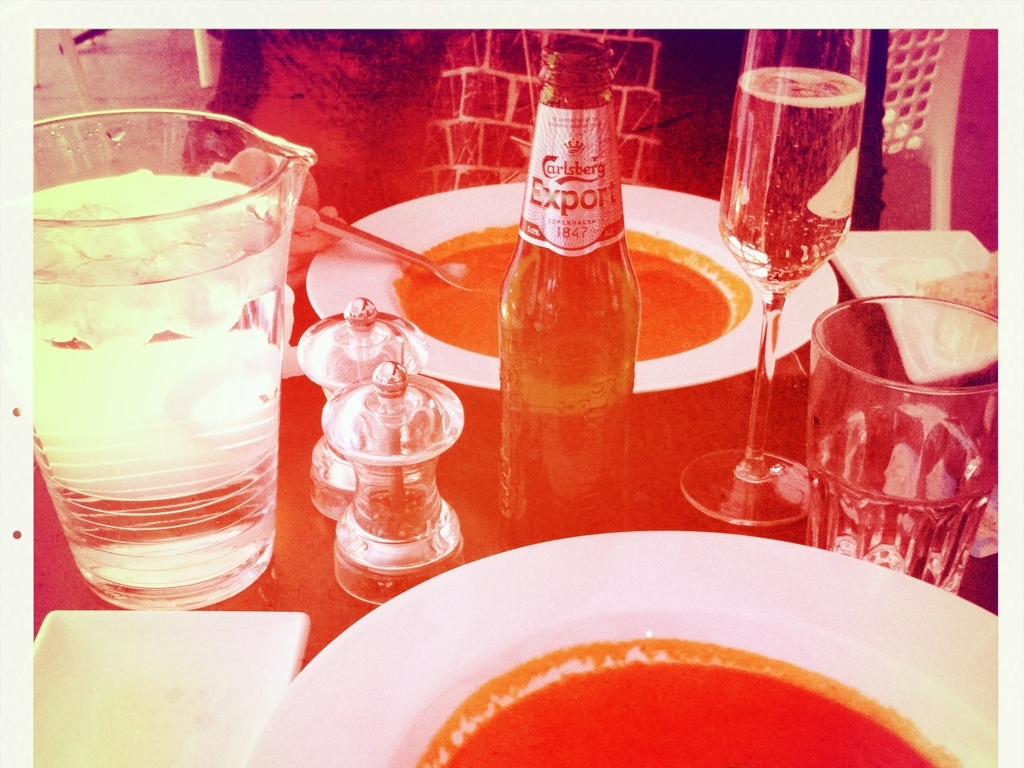Are there any quality issues with this image? Yes, the image appears to have a heavy red and yellow color tint, which might be a deliberate stylistic choice but can be considered a quality issue as it obscures the natural colors of the scene. It also seems slightly overexposed, especially in the areas where the light is strongest, such as at the top of the image. 